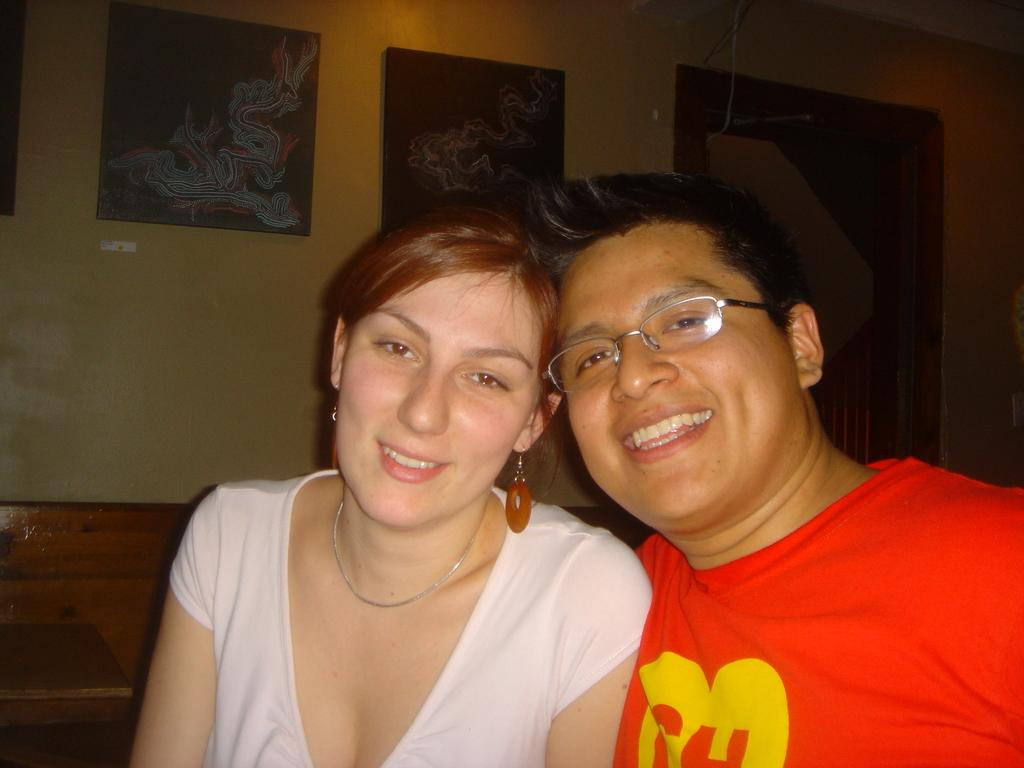Who can be seen in the foreground of the image? There is a man and a woman in the foreground of the image. What expressions do the man and woman have in the image? Both the man and the woman are smiling in the image. What can be seen on the wall in the background of the image? There are photo frames on the wall in the background of the image. What type of table is visible in the background of the image? There is a wooden table in the background of the image. What is the main architectural feature in the background of the image? There is a wall in the background of the image. What type of punishment is being administered to the man and woman in the image? There is no punishment being administered to the man and woman in the image; they are both smiling. What kind of stem is visible in the image? There is no stem present in the image. 